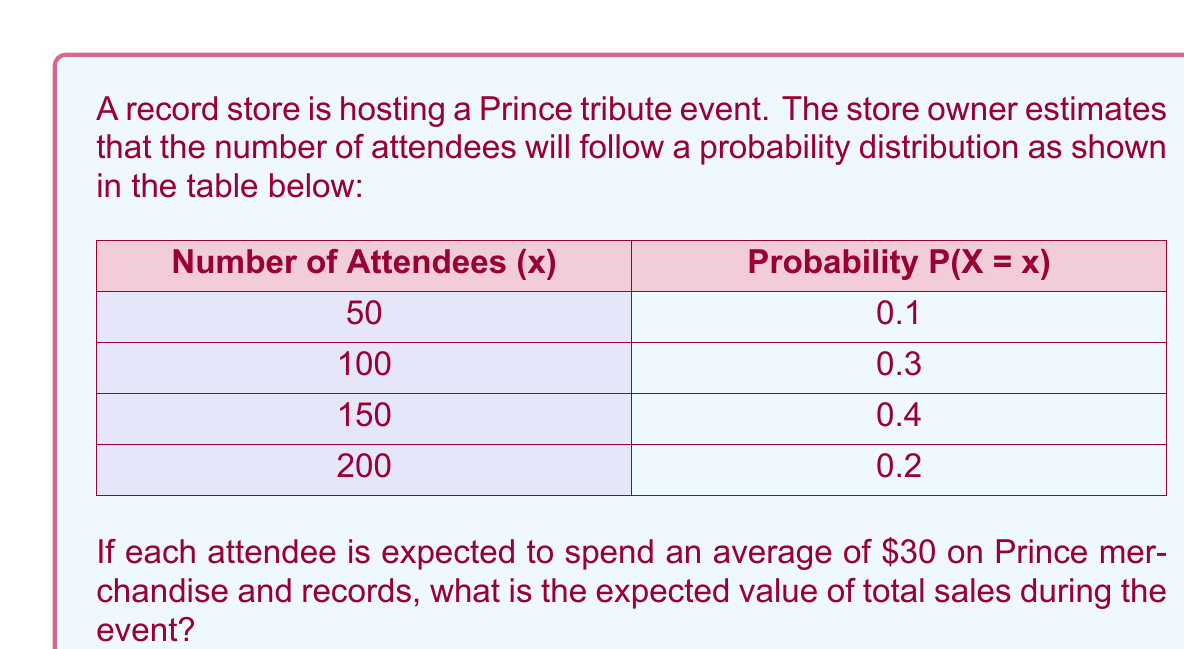Solve this math problem. To calculate the expected value of total sales, we need to follow these steps:

1. Calculate the expected number of attendees:
   $$E(X) = \sum_{x} x \cdot P(X = x)$$
   $$E(X) = 50 \cdot 0.1 + 100 \cdot 0.3 + 150 \cdot 0.4 + 200 \cdot 0.2$$
   $$E(X) = 5 + 30 + 60 + 40 = 135$$

2. Calculate the expected sales per attendee:
   Given that each attendee is expected to spend an average of $30, we can use this as our expected sales per attendee.

3. Calculate the expected value of total sales:
   $$E(\text{Total Sales}) = E(X) \cdot \text{Expected sales per attendee}$$
   $$E(\text{Total Sales}) = 135 \cdot \$30 = \$4,050$$

Therefore, the expected value of total sales during the Prince tribute event is $4,050.
Answer: $4,050 